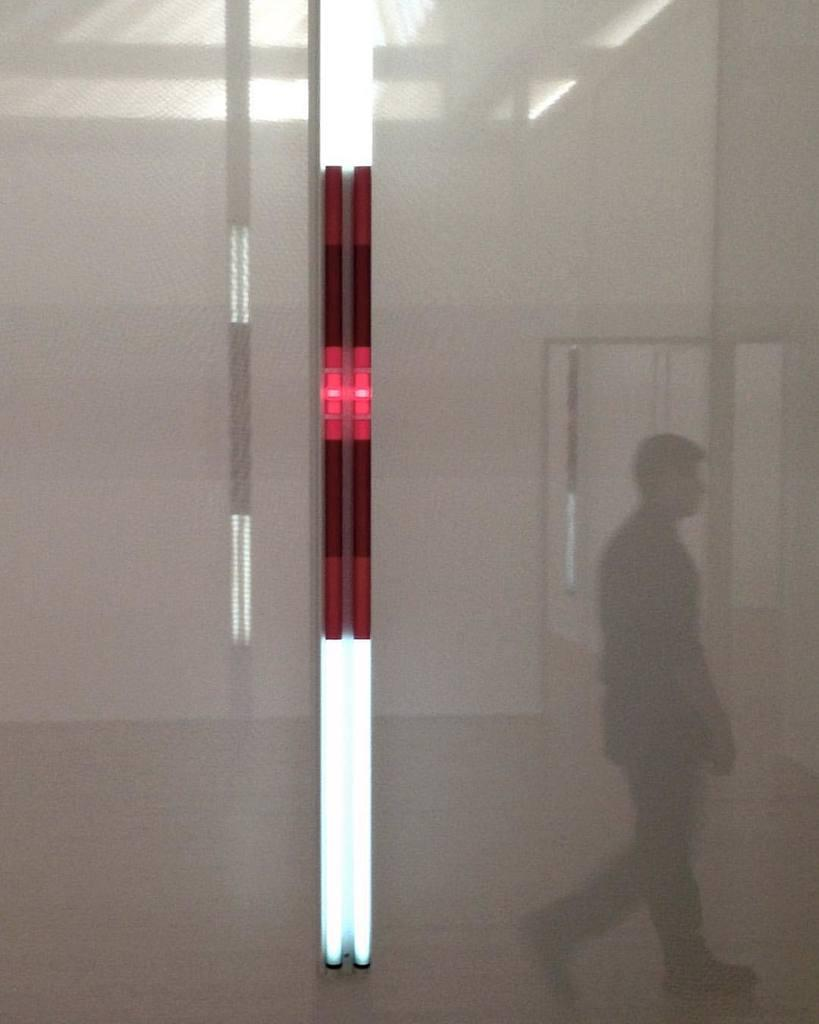What is the main object in the center of the image? There is a light in the center of the image. What is happening on the right side of the image? There is a person walking on the right side of the image. Can you describe the background of the image? There is a light and a door in the background of the image. Where is the hose located in the image? There is no hose present in the image. What type of memory is being stored in the person's mind in the image? The image does not provide any information about the person's thoughts or memories. 